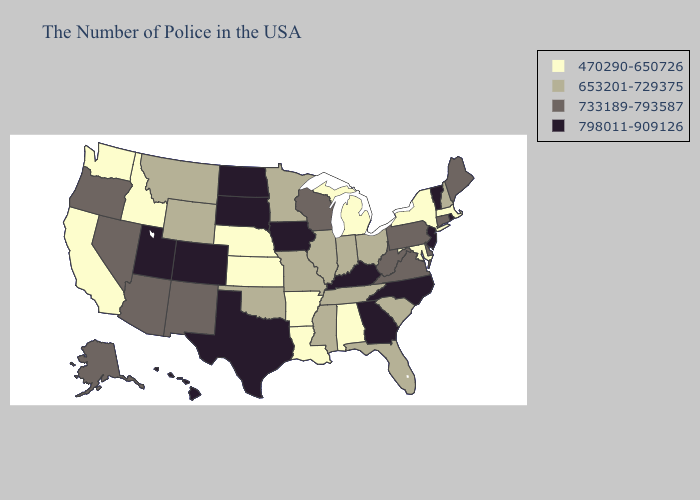Does West Virginia have the lowest value in the South?
Short answer required. No. Among the states that border California , which have the lowest value?
Answer briefly. Arizona, Nevada, Oregon. Does Iowa have a lower value than Utah?
Answer briefly. No. What is the lowest value in the South?
Concise answer only. 470290-650726. Name the states that have a value in the range 733189-793587?
Concise answer only. Maine, Connecticut, Delaware, Pennsylvania, Virginia, West Virginia, Wisconsin, New Mexico, Arizona, Nevada, Oregon, Alaska. What is the value of Arizona?
Concise answer only. 733189-793587. Among the states that border Montana , does Wyoming have the highest value?
Give a very brief answer. No. Which states have the lowest value in the MidWest?
Write a very short answer. Michigan, Kansas, Nebraska. Is the legend a continuous bar?
Be succinct. No. Does Arkansas have the lowest value in the South?
Keep it brief. Yes. What is the value of Delaware?
Concise answer only. 733189-793587. Does Mississippi have the same value as Alabama?
Concise answer only. No. Which states hav the highest value in the West?
Give a very brief answer. Colorado, Utah, Hawaii. Name the states that have a value in the range 653201-729375?
Be succinct. New Hampshire, South Carolina, Ohio, Florida, Indiana, Tennessee, Illinois, Mississippi, Missouri, Minnesota, Oklahoma, Wyoming, Montana. Among the states that border Ohio , does West Virginia have the lowest value?
Write a very short answer. No. 